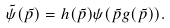Convert formula to latex. <formula><loc_0><loc_0><loc_500><loc_500>\tilde { \psi } ( \tilde { p } ) = h ( \tilde { p } ) \psi ( \tilde { p } g ( \tilde { p } ) ) .</formula> 